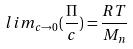<formula> <loc_0><loc_0><loc_500><loc_500>l i m _ { c \rightarrow 0 } ( \frac { \Pi } { c } ) = \frac { R T } { M _ { n } }</formula> 